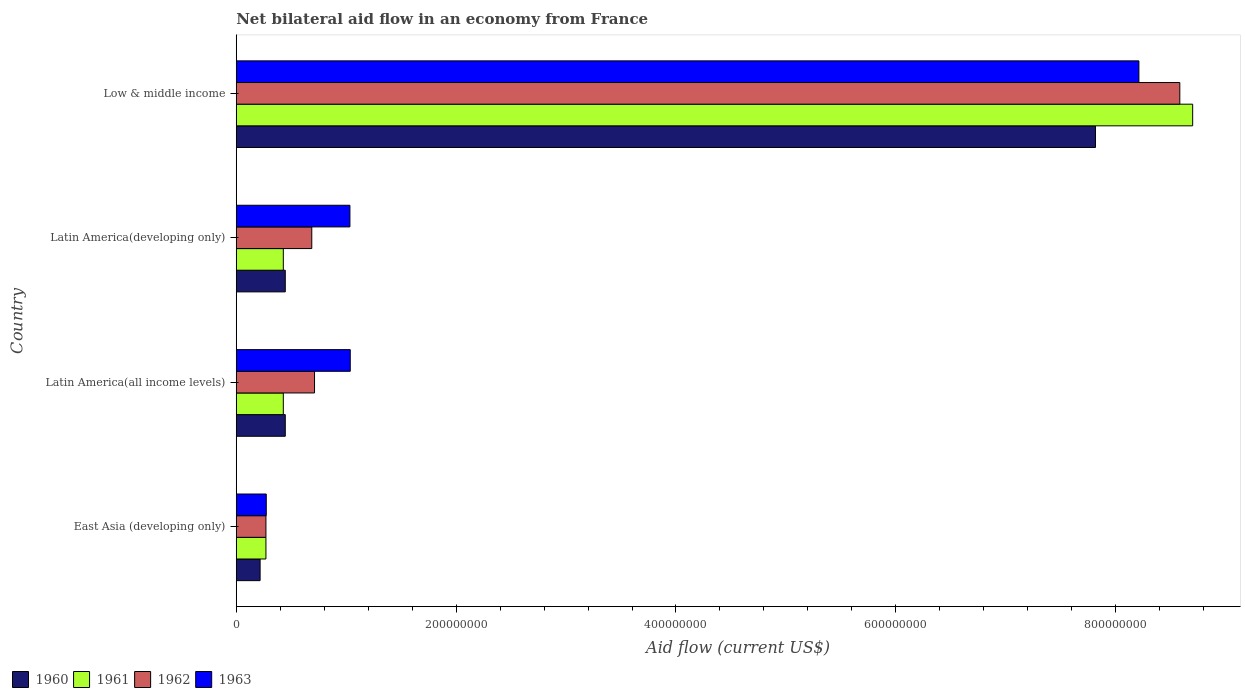How many different coloured bars are there?
Keep it short and to the point. 4. How many groups of bars are there?
Ensure brevity in your answer.  4. Are the number of bars on each tick of the Y-axis equal?
Your answer should be compact. Yes. How many bars are there on the 4th tick from the top?
Make the answer very short. 4. How many bars are there on the 1st tick from the bottom?
Make the answer very short. 4. What is the label of the 2nd group of bars from the top?
Give a very brief answer. Latin America(developing only). What is the net bilateral aid flow in 1962 in Low & middle income?
Offer a terse response. 8.58e+08. Across all countries, what is the maximum net bilateral aid flow in 1961?
Offer a terse response. 8.70e+08. Across all countries, what is the minimum net bilateral aid flow in 1960?
Your response must be concise. 2.17e+07. In which country was the net bilateral aid flow in 1961 minimum?
Offer a terse response. East Asia (developing only). What is the total net bilateral aid flow in 1963 in the graph?
Offer a very short reply. 1.06e+09. What is the difference between the net bilateral aid flow in 1961 in East Asia (developing only) and that in Low & middle income?
Ensure brevity in your answer.  -8.43e+08. What is the difference between the net bilateral aid flow in 1962 in Latin America(developing only) and the net bilateral aid flow in 1961 in Low & middle income?
Provide a succinct answer. -8.01e+08. What is the average net bilateral aid flow in 1961 per country?
Provide a succinct answer. 2.46e+08. What is the ratio of the net bilateral aid flow in 1963 in Latin America(all income levels) to that in Low & middle income?
Your response must be concise. 0.13. Is the net bilateral aid flow in 1962 in East Asia (developing only) less than that in Low & middle income?
Your response must be concise. Yes. Is the difference between the net bilateral aid flow in 1961 in East Asia (developing only) and Low & middle income greater than the difference between the net bilateral aid flow in 1963 in East Asia (developing only) and Low & middle income?
Keep it short and to the point. No. What is the difference between the highest and the second highest net bilateral aid flow in 1960?
Offer a very short reply. 7.37e+08. What is the difference between the highest and the lowest net bilateral aid flow in 1962?
Make the answer very short. 8.31e+08. Is it the case that in every country, the sum of the net bilateral aid flow in 1961 and net bilateral aid flow in 1963 is greater than the sum of net bilateral aid flow in 1962 and net bilateral aid flow in 1960?
Your answer should be compact. No. What does the 1st bar from the top in Low & middle income represents?
Offer a very short reply. 1963. What does the 2nd bar from the bottom in Latin America(developing only) represents?
Provide a succinct answer. 1961. Is it the case that in every country, the sum of the net bilateral aid flow in 1962 and net bilateral aid flow in 1963 is greater than the net bilateral aid flow in 1960?
Your answer should be compact. Yes. How many countries are there in the graph?
Offer a very short reply. 4. Are the values on the major ticks of X-axis written in scientific E-notation?
Make the answer very short. No. Does the graph contain any zero values?
Offer a very short reply. No. Does the graph contain grids?
Ensure brevity in your answer.  No. Where does the legend appear in the graph?
Ensure brevity in your answer.  Bottom left. How many legend labels are there?
Make the answer very short. 4. How are the legend labels stacked?
Ensure brevity in your answer.  Horizontal. What is the title of the graph?
Make the answer very short. Net bilateral aid flow in an economy from France. Does "2003" appear as one of the legend labels in the graph?
Your answer should be compact. No. What is the Aid flow (current US$) in 1960 in East Asia (developing only)?
Your response must be concise. 2.17e+07. What is the Aid flow (current US$) in 1961 in East Asia (developing only)?
Offer a very short reply. 2.70e+07. What is the Aid flow (current US$) of 1962 in East Asia (developing only)?
Offer a very short reply. 2.70e+07. What is the Aid flow (current US$) in 1963 in East Asia (developing only)?
Give a very brief answer. 2.73e+07. What is the Aid flow (current US$) in 1960 in Latin America(all income levels)?
Your answer should be very brief. 4.46e+07. What is the Aid flow (current US$) in 1961 in Latin America(all income levels)?
Provide a succinct answer. 4.28e+07. What is the Aid flow (current US$) of 1962 in Latin America(all income levels)?
Your answer should be very brief. 7.12e+07. What is the Aid flow (current US$) of 1963 in Latin America(all income levels)?
Provide a succinct answer. 1.04e+08. What is the Aid flow (current US$) in 1960 in Latin America(developing only)?
Your response must be concise. 4.46e+07. What is the Aid flow (current US$) of 1961 in Latin America(developing only)?
Ensure brevity in your answer.  4.28e+07. What is the Aid flow (current US$) of 1962 in Latin America(developing only)?
Offer a very short reply. 6.87e+07. What is the Aid flow (current US$) in 1963 in Latin America(developing only)?
Ensure brevity in your answer.  1.03e+08. What is the Aid flow (current US$) in 1960 in Low & middle income?
Provide a succinct answer. 7.82e+08. What is the Aid flow (current US$) of 1961 in Low & middle income?
Your answer should be compact. 8.70e+08. What is the Aid flow (current US$) of 1962 in Low & middle income?
Provide a short and direct response. 8.58e+08. What is the Aid flow (current US$) in 1963 in Low & middle income?
Keep it short and to the point. 8.21e+08. Across all countries, what is the maximum Aid flow (current US$) in 1960?
Provide a succinct answer. 7.82e+08. Across all countries, what is the maximum Aid flow (current US$) in 1961?
Ensure brevity in your answer.  8.70e+08. Across all countries, what is the maximum Aid flow (current US$) of 1962?
Give a very brief answer. 8.58e+08. Across all countries, what is the maximum Aid flow (current US$) in 1963?
Ensure brevity in your answer.  8.21e+08. Across all countries, what is the minimum Aid flow (current US$) in 1960?
Offer a very short reply. 2.17e+07. Across all countries, what is the minimum Aid flow (current US$) of 1961?
Offer a terse response. 2.70e+07. Across all countries, what is the minimum Aid flow (current US$) of 1962?
Give a very brief answer. 2.70e+07. Across all countries, what is the minimum Aid flow (current US$) of 1963?
Your answer should be compact. 2.73e+07. What is the total Aid flow (current US$) of 1960 in the graph?
Your answer should be very brief. 8.92e+08. What is the total Aid flow (current US$) in 1961 in the graph?
Your response must be concise. 9.83e+08. What is the total Aid flow (current US$) of 1962 in the graph?
Provide a short and direct response. 1.03e+09. What is the total Aid flow (current US$) of 1963 in the graph?
Offer a very short reply. 1.06e+09. What is the difference between the Aid flow (current US$) in 1960 in East Asia (developing only) and that in Latin America(all income levels)?
Provide a succinct answer. -2.29e+07. What is the difference between the Aid flow (current US$) of 1961 in East Asia (developing only) and that in Latin America(all income levels)?
Make the answer very short. -1.58e+07. What is the difference between the Aid flow (current US$) of 1962 in East Asia (developing only) and that in Latin America(all income levels)?
Keep it short and to the point. -4.42e+07. What is the difference between the Aid flow (current US$) in 1963 in East Asia (developing only) and that in Latin America(all income levels)?
Offer a very short reply. -7.64e+07. What is the difference between the Aid flow (current US$) of 1960 in East Asia (developing only) and that in Latin America(developing only)?
Your response must be concise. -2.29e+07. What is the difference between the Aid flow (current US$) in 1961 in East Asia (developing only) and that in Latin America(developing only)?
Provide a short and direct response. -1.58e+07. What is the difference between the Aid flow (current US$) of 1962 in East Asia (developing only) and that in Latin America(developing only)?
Make the answer very short. -4.17e+07. What is the difference between the Aid flow (current US$) in 1963 in East Asia (developing only) and that in Latin America(developing only)?
Make the answer very short. -7.61e+07. What is the difference between the Aid flow (current US$) of 1960 in East Asia (developing only) and that in Low & middle income?
Provide a succinct answer. -7.60e+08. What is the difference between the Aid flow (current US$) of 1961 in East Asia (developing only) and that in Low & middle income?
Provide a succinct answer. -8.43e+08. What is the difference between the Aid flow (current US$) of 1962 in East Asia (developing only) and that in Low & middle income?
Your answer should be compact. -8.31e+08. What is the difference between the Aid flow (current US$) of 1963 in East Asia (developing only) and that in Low & middle income?
Ensure brevity in your answer.  -7.94e+08. What is the difference between the Aid flow (current US$) in 1961 in Latin America(all income levels) and that in Latin America(developing only)?
Your answer should be compact. 0. What is the difference between the Aid flow (current US$) in 1962 in Latin America(all income levels) and that in Latin America(developing only)?
Offer a very short reply. 2.50e+06. What is the difference between the Aid flow (current US$) of 1960 in Latin America(all income levels) and that in Low & middle income?
Keep it short and to the point. -7.37e+08. What is the difference between the Aid flow (current US$) of 1961 in Latin America(all income levels) and that in Low & middle income?
Your answer should be compact. -8.27e+08. What is the difference between the Aid flow (current US$) in 1962 in Latin America(all income levels) and that in Low & middle income?
Offer a very short reply. -7.87e+08. What is the difference between the Aid flow (current US$) of 1963 in Latin America(all income levels) and that in Low & middle income?
Offer a terse response. -7.17e+08. What is the difference between the Aid flow (current US$) of 1960 in Latin America(developing only) and that in Low & middle income?
Provide a short and direct response. -7.37e+08. What is the difference between the Aid flow (current US$) in 1961 in Latin America(developing only) and that in Low & middle income?
Your response must be concise. -8.27e+08. What is the difference between the Aid flow (current US$) in 1962 in Latin America(developing only) and that in Low & middle income?
Offer a very short reply. -7.90e+08. What is the difference between the Aid flow (current US$) in 1963 in Latin America(developing only) and that in Low & middle income?
Give a very brief answer. -7.18e+08. What is the difference between the Aid flow (current US$) of 1960 in East Asia (developing only) and the Aid flow (current US$) of 1961 in Latin America(all income levels)?
Give a very brief answer. -2.11e+07. What is the difference between the Aid flow (current US$) of 1960 in East Asia (developing only) and the Aid flow (current US$) of 1962 in Latin America(all income levels)?
Make the answer very short. -4.95e+07. What is the difference between the Aid flow (current US$) of 1960 in East Asia (developing only) and the Aid flow (current US$) of 1963 in Latin America(all income levels)?
Give a very brief answer. -8.20e+07. What is the difference between the Aid flow (current US$) of 1961 in East Asia (developing only) and the Aid flow (current US$) of 1962 in Latin America(all income levels)?
Your answer should be very brief. -4.42e+07. What is the difference between the Aid flow (current US$) of 1961 in East Asia (developing only) and the Aid flow (current US$) of 1963 in Latin America(all income levels)?
Your response must be concise. -7.67e+07. What is the difference between the Aid flow (current US$) in 1962 in East Asia (developing only) and the Aid flow (current US$) in 1963 in Latin America(all income levels)?
Your response must be concise. -7.67e+07. What is the difference between the Aid flow (current US$) in 1960 in East Asia (developing only) and the Aid flow (current US$) in 1961 in Latin America(developing only)?
Your answer should be compact. -2.11e+07. What is the difference between the Aid flow (current US$) of 1960 in East Asia (developing only) and the Aid flow (current US$) of 1962 in Latin America(developing only)?
Provide a short and direct response. -4.70e+07. What is the difference between the Aid flow (current US$) of 1960 in East Asia (developing only) and the Aid flow (current US$) of 1963 in Latin America(developing only)?
Offer a very short reply. -8.17e+07. What is the difference between the Aid flow (current US$) in 1961 in East Asia (developing only) and the Aid flow (current US$) in 1962 in Latin America(developing only)?
Provide a succinct answer. -4.17e+07. What is the difference between the Aid flow (current US$) of 1961 in East Asia (developing only) and the Aid flow (current US$) of 1963 in Latin America(developing only)?
Give a very brief answer. -7.64e+07. What is the difference between the Aid flow (current US$) in 1962 in East Asia (developing only) and the Aid flow (current US$) in 1963 in Latin America(developing only)?
Offer a very short reply. -7.64e+07. What is the difference between the Aid flow (current US$) in 1960 in East Asia (developing only) and the Aid flow (current US$) in 1961 in Low & middle income?
Ensure brevity in your answer.  -8.48e+08. What is the difference between the Aid flow (current US$) of 1960 in East Asia (developing only) and the Aid flow (current US$) of 1962 in Low & middle income?
Provide a short and direct response. -8.37e+08. What is the difference between the Aid flow (current US$) in 1960 in East Asia (developing only) and the Aid flow (current US$) in 1963 in Low & middle income?
Provide a succinct answer. -7.99e+08. What is the difference between the Aid flow (current US$) in 1961 in East Asia (developing only) and the Aid flow (current US$) in 1962 in Low & middle income?
Give a very brief answer. -8.31e+08. What is the difference between the Aid flow (current US$) of 1961 in East Asia (developing only) and the Aid flow (current US$) of 1963 in Low & middle income?
Your answer should be very brief. -7.94e+08. What is the difference between the Aid flow (current US$) in 1962 in East Asia (developing only) and the Aid flow (current US$) in 1963 in Low & middle income?
Your answer should be compact. -7.94e+08. What is the difference between the Aid flow (current US$) in 1960 in Latin America(all income levels) and the Aid flow (current US$) in 1961 in Latin America(developing only)?
Offer a terse response. 1.80e+06. What is the difference between the Aid flow (current US$) in 1960 in Latin America(all income levels) and the Aid flow (current US$) in 1962 in Latin America(developing only)?
Your answer should be compact. -2.41e+07. What is the difference between the Aid flow (current US$) of 1960 in Latin America(all income levels) and the Aid flow (current US$) of 1963 in Latin America(developing only)?
Your answer should be very brief. -5.88e+07. What is the difference between the Aid flow (current US$) of 1961 in Latin America(all income levels) and the Aid flow (current US$) of 1962 in Latin America(developing only)?
Your answer should be compact. -2.59e+07. What is the difference between the Aid flow (current US$) in 1961 in Latin America(all income levels) and the Aid flow (current US$) in 1963 in Latin America(developing only)?
Offer a terse response. -6.06e+07. What is the difference between the Aid flow (current US$) of 1962 in Latin America(all income levels) and the Aid flow (current US$) of 1963 in Latin America(developing only)?
Give a very brief answer. -3.22e+07. What is the difference between the Aid flow (current US$) in 1960 in Latin America(all income levels) and the Aid flow (current US$) in 1961 in Low & middle income?
Offer a terse response. -8.25e+08. What is the difference between the Aid flow (current US$) in 1960 in Latin America(all income levels) and the Aid flow (current US$) in 1962 in Low & middle income?
Your response must be concise. -8.14e+08. What is the difference between the Aid flow (current US$) in 1960 in Latin America(all income levels) and the Aid flow (current US$) in 1963 in Low & middle income?
Ensure brevity in your answer.  -7.76e+08. What is the difference between the Aid flow (current US$) of 1961 in Latin America(all income levels) and the Aid flow (current US$) of 1962 in Low & middle income?
Make the answer very short. -8.16e+08. What is the difference between the Aid flow (current US$) of 1961 in Latin America(all income levels) and the Aid flow (current US$) of 1963 in Low & middle income?
Your response must be concise. -7.78e+08. What is the difference between the Aid flow (current US$) in 1962 in Latin America(all income levels) and the Aid flow (current US$) in 1963 in Low & middle income?
Give a very brief answer. -7.50e+08. What is the difference between the Aid flow (current US$) of 1960 in Latin America(developing only) and the Aid flow (current US$) of 1961 in Low & middle income?
Your answer should be compact. -8.25e+08. What is the difference between the Aid flow (current US$) in 1960 in Latin America(developing only) and the Aid flow (current US$) in 1962 in Low & middle income?
Provide a succinct answer. -8.14e+08. What is the difference between the Aid flow (current US$) in 1960 in Latin America(developing only) and the Aid flow (current US$) in 1963 in Low & middle income?
Your answer should be compact. -7.76e+08. What is the difference between the Aid flow (current US$) of 1961 in Latin America(developing only) and the Aid flow (current US$) of 1962 in Low & middle income?
Offer a very short reply. -8.16e+08. What is the difference between the Aid flow (current US$) in 1961 in Latin America(developing only) and the Aid flow (current US$) in 1963 in Low & middle income?
Ensure brevity in your answer.  -7.78e+08. What is the difference between the Aid flow (current US$) of 1962 in Latin America(developing only) and the Aid flow (current US$) of 1963 in Low & middle income?
Ensure brevity in your answer.  -7.52e+08. What is the average Aid flow (current US$) in 1960 per country?
Offer a very short reply. 2.23e+08. What is the average Aid flow (current US$) of 1961 per country?
Keep it short and to the point. 2.46e+08. What is the average Aid flow (current US$) of 1962 per country?
Your answer should be compact. 2.56e+08. What is the average Aid flow (current US$) of 1963 per country?
Offer a terse response. 2.64e+08. What is the difference between the Aid flow (current US$) of 1960 and Aid flow (current US$) of 1961 in East Asia (developing only)?
Your response must be concise. -5.30e+06. What is the difference between the Aid flow (current US$) of 1960 and Aid flow (current US$) of 1962 in East Asia (developing only)?
Ensure brevity in your answer.  -5.30e+06. What is the difference between the Aid flow (current US$) in 1960 and Aid flow (current US$) in 1963 in East Asia (developing only)?
Your answer should be very brief. -5.60e+06. What is the difference between the Aid flow (current US$) in 1961 and Aid flow (current US$) in 1962 in East Asia (developing only)?
Offer a very short reply. 0. What is the difference between the Aid flow (current US$) of 1960 and Aid flow (current US$) of 1961 in Latin America(all income levels)?
Offer a very short reply. 1.80e+06. What is the difference between the Aid flow (current US$) in 1960 and Aid flow (current US$) in 1962 in Latin America(all income levels)?
Offer a very short reply. -2.66e+07. What is the difference between the Aid flow (current US$) in 1960 and Aid flow (current US$) in 1963 in Latin America(all income levels)?
Offer a terse response. -5.91e+07. What is the difference between the Aid flow (current US$) of 1961 and Aid flow (current US$) of 1962 in Latin America(all income levels)?
Keep it short and to the point. -2.84e+07. What is the difference between the Aid flow (current US$) in 1961 and Aid flow (current US$) in 1963 in Latin America(all income levels)?
Ensure brevity in your answer.  -6.09e+07. What is the difference between the Aid flow (current US$) in 1962 and Aid flow (current US$) in 1963 in Latin America(all income levels)?
Keep it short and to the point. -3.25e+07. What is the difference between the Aid flow (current US$) in 1960 and Aid flow (current US$) in 1961 in Latin America(developing only)?
Keep it short and to the point. 1.80e+06. What is the difference between the Aid flow (current US$) of 1960 and Aid flow (current US$) of 1962 in Latin America(developing only)?
Your answer should be compact. -2.41e+07. What is the difference between the Aid flow (current US$) of 1960 and Aid flow (current US$) of 1963 in Latin America(developing only)?
Ensure brevity in your answer.  -5.88e+07. What is the difference between the Aid flow (current US$) of 1961 and Aid flow (current US$) of 1962 in Latin America(developing only)?
Provide a succinct answer. -2.59e+07. What is the difference between the Aid flow (current US$) in 1961 and Aid flow (current US$) in 1963 in Latin America(developing only)?
Offer a very short reply. -6.06e+07. What is the difference between the Aid flow (current US$) of 1962 and Aid flow (current US$) of 1963 in Latin America(developing only)?
Your response must be concise. -3.47e+07. What is the difference between the Aid flow (current US$) in 1960 and Aid flow (current US$) in 1961 in Low & middle income?
Your response must be concise. -8.84e+07. What is the difference between the Aid flow (current US$) in 1960 and Aid flow (current US$) in 1962 in Low & middle income?
Provide a short and direct response. -7.67e+07. What is the difference between the Aid flow (current US$) in 1960 and Aid flow (current US$) in 1963 in Low & middle income?
Provide a short and direct response. -3.95e+07. What is the difference between the Aid flow (current US$) of 1961 and Aid flow (current US$) of 1962 in Low & middle income?
Ensure brevity in your answer.  1.17e+07. What is the difference between the Aid flow (current US$) in 1961 and Aid flow (current US$) in 1963 in Low & middle income?
Ensure brevity in your answer.  4.89e+07. What is the difference between the Aid flow (current US$) in 1962 and Aid flow (current US$) in 1963 in Low & middle income?
Your response must be concise. 3.72e+07. What is the ratio of the Aid flow (current US$) in 1960 in East Asia (developing only) to that in Latin America(all income levels)?
Provide a short and direct response. 0.49. What is the ratio of the Aid flow (current US$) in 1961 in East Asia (developing only) to that in Latin America(all income levels)?
Provide a succinct answer. 0.63. What is the ratio of the Aid flow (current US$) in 1962 in East Asia (developing only) to that in Latin America(all income levels)?
Offer a terse response. 0.38. What is the ratio of the Aid flow (current US$) of 1963 in East Asia (developing only) to that in Latin America(all income levels)?
Offer a very short reply. 0.26. What is the ratio of the Aid flow (current US$) of 1960 in East Asia (developing only) to that in Latin America(developing only)?
Ensure brevity in your answer.  0.49. What is the ratio of the Aid flow (current US$) in 1961 in East Asia (developing only) to that in Latin America(developing only)?
Provide a succinct answer. 0.63. What is the ratio of the Aid flow (current US$) in 1962 in East Asia (developing only) to that in Latin America(developing only)?
Keep it short and to the point. 0.39. What is the ratio of the Aid flow (current US$) of 1963 in East Asia (developing only) to that in Latin America(developing only)?
Give a very brief answer. 0.26. What is the ratio of the Aid flow (current US$) of 1960 in East Asia (developing only) to that in Low & middle income?
Make the answer very short. 0.03. What is the ratio of the Aid flow (current US$) of 1961 in East Asia (developing only) to that in Low & middle income?
Your response must be concise. 0.03. What is the ratio of the Aid flow (current US$) in 1962 in East Asia (developing only) to that in Low & middle income?
Your answer should be compact. 0.03. What is the ratio of the Aid flow (current US$) of 1963 in East Asia (developing only) to that in Low & middle income?
Provide a succinct answer. 0.03. What is the ratio of the Aid flow (current US$) in 1960 in Latin America(all income levels) to that in Latin America(developing only)?
Offer a very short reply. 1. What is the ratio of the Aid flow (current US$) of 1962 in Latin America(all income levels) to that in Latin America(developing only)?
Keep it short and to the point. 1.04. What is the ratio of the Aid flow (current US$) of 1963 in Latin America(all income levels) to that in Latin America(developing only)?
Ensure brevity in your answer.  1. What is the ratio of the Aid flow (current US$) of 1960 in Latin America(all income levels) to that in Low & middle income?
Give a very brief answer. 0.06. What is the ratio of the Aid flow (current US$) in 1961 in Latin America(all income levels) to that in Low & middle income?
Your answer should be compact. 0.05. What is the ratio of the Aid flow (current US$) in 1962 in Latin America(all income levels) to that in Low & middle income?
Your answer should be very brief. 0.08. What is the ratio of the Aid flow (current US$) in 1963 in Latin America(all income levels) to that in Low & middle income?
Your response must be concise. 0.13. What is the ratio of the Aid flow (current US$) of 1960 in Latin America(developing only) to that in Low & middle income?
Your response must be concise. 0.06. What is the ratio of the Aid flow (current US$) in 1961 in Latin America(developing only) to that in Low & middle income?
Provide a succinct answer. 0.05. What is the ratio of the Aid flow (current US$) in 1963 in Latin America(developing only) to that in Low & middle income?
Offer a very short reply. 0.13. What is the difference between the highest and the second highest Aid flow (current US$) in 1960?
Offer a terse response. 7.37e+08. What is the difference between the highest and the second highest Aid flow (current US$) of 1961?
Your response must be concise. 8.27e+08. What is the difference between the highest and the second highest Aid flow (current US$) of 1962?
Ensure brevity in your answer.  7.87e+08. What is the difference between the highest and the second highest Aid flow (current US$) in 1963?
Offer a very short reply. 7.17e+08. What is the difference between the highest and the lowest Aid flow (current US$) in 1960?
Offer a very short reply. 7.60e+08. What is the difference between the highest and the lowest Aid flow (current US$) of 1961?
Offer a very short reply. 8.43e+08. What is the difference between the highest and the lowest Aid flow (current US$) in 1962?
Provide a short and direct response. 8.31e+08. What is the difference between the highest and the lowest Aid flow (current US$) in 1963?
Make the answer very short. 7.94e+08. 